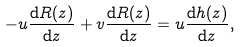Convert formula to latex. <formula><loc_0><loc_0><loc_500><loc_500>- u \frac { { \mathrm d } R ( z ) } { { \mathrm d } z } + v \frac { { \mathrm d } R ( z ) } { { \mathrm d } z } = u \frac { { \mathrm d } h ( z ) } { { \mathrm d } z } ,</formula> 